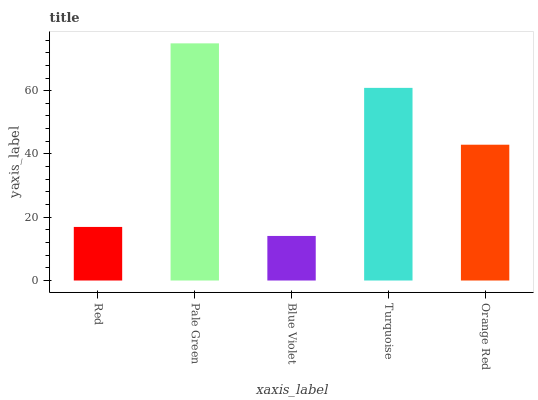Is Blue Violet the minimum?
Answer yes or no. Yes. Is Pale Green the maximum?
Answer yes or no. Yes. Is Pale Green the minimum?
Answer yes or no. No. Is Blue Violet the maximum?
Answer yes or no. No. Is Pale Green greater than Blue Violet?
Answer yes or no. Yes. Is Blue Violet less than Pale Green?
Answer yes or no. Yes. Is Blue Violet greater than Pale Green?
Answer yes or no. No. Is Pale Green less than Blue Violet?
Answer yes or no. No. Is Orange Red the high median?
Answer yes or no. Yes. Is Orange Red the low median?
Answer yes or no. Yes. Is Pale Green the high median?
Answer yes or no. No. Is Red the low median?
Answer yes or no. No. 